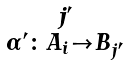<formula> <loc_0><loc_0><loc_500><loc_500>\begin{smallmatrix} j ^ { \prime } \\ \alpha ^ { \prime } \colon A _ { i } \to B _ { j ^ { \prime } } \end{smallmatrix}</formula> 